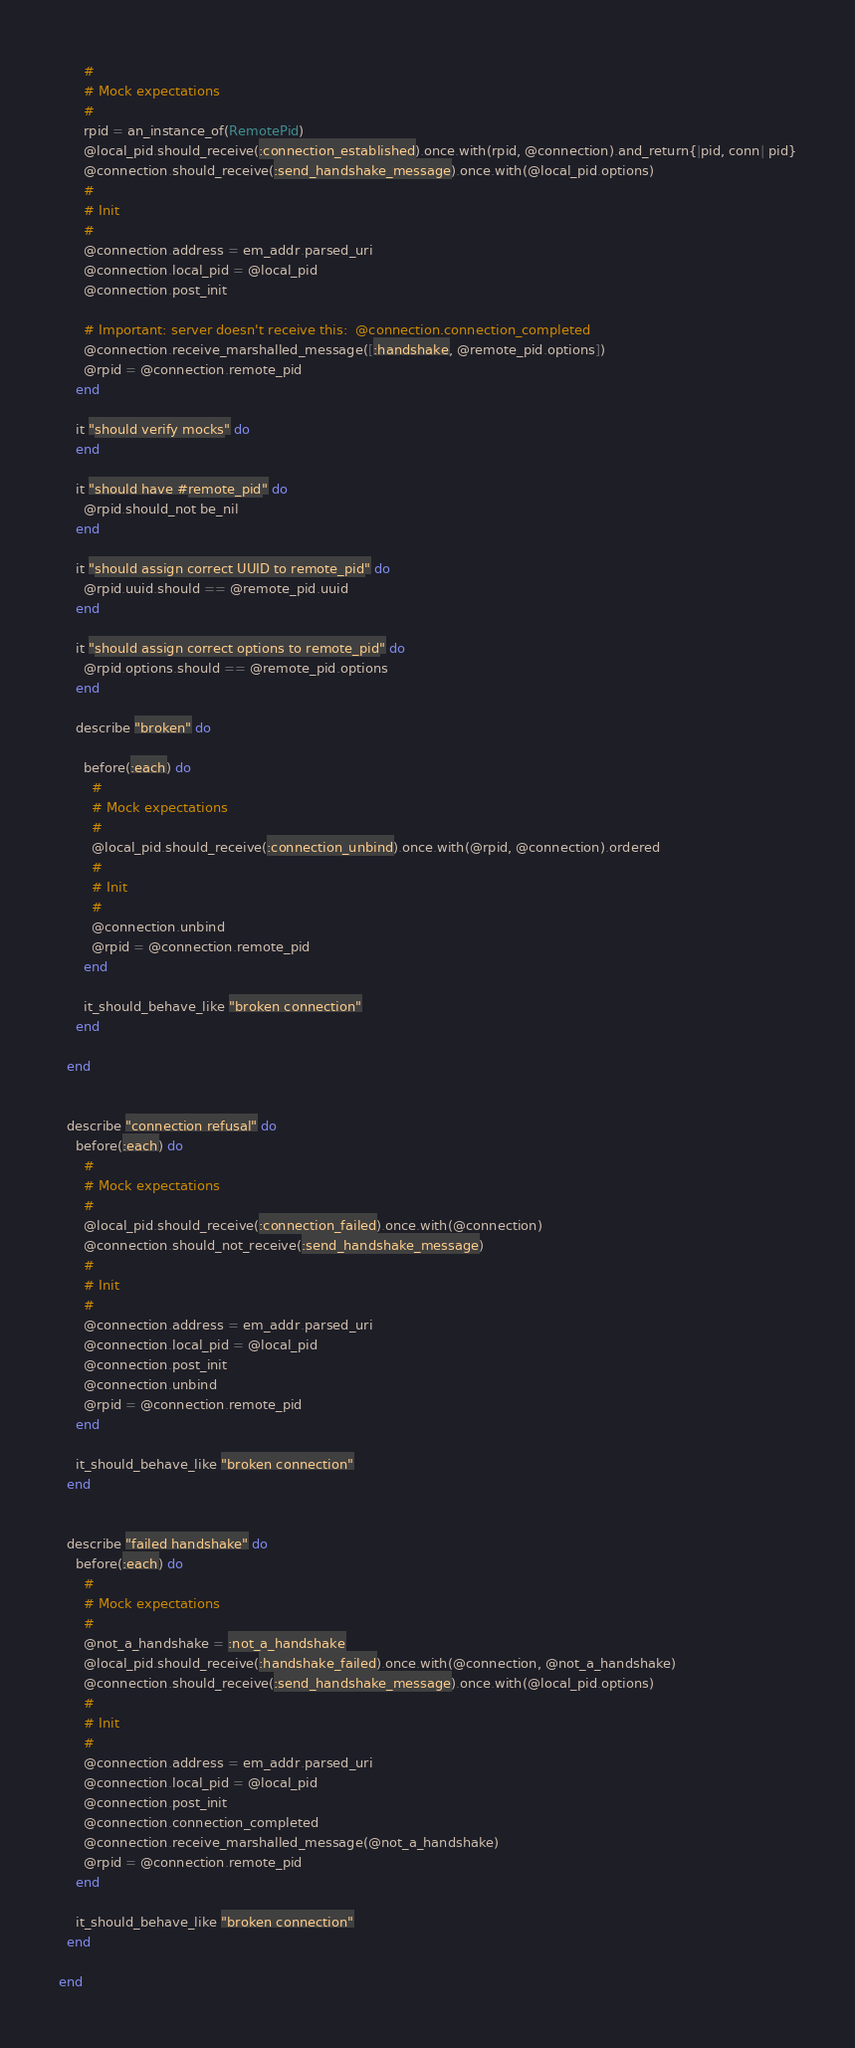<code> <loc_0><loc_0><loc_500><loc_500><_Ruby_>      #
      # Mock expectations
      #
      rpid = an_instance_of(RemotePid)
      @local_pid.should_receive(:connection_established).once.with(rpid, @connection).and_return{|pid, conn| pid}
      @connection.should_receive(:send_handshake_message).once.with(@local_pid.options)
      #
      # Init
      #
      @connection.address = em_addr.parsed_uri
      @connection.local_pid = @local_pid
      @connection.post_init
      
      # Important: server doesn't receive this:  @connection.connection_completed
      @connection.receive_marshalled_message([:handshake, @remote_pid.options])
      @rpid = @connection.remote_pid
    end
    
    it "should verify mocks" do
    end
    
    it "should have #remote_pid" do
      @rpid.should_not be_nil
    end
    
    it "should assign correct UUID to remote_pid" do
      @rpid.uuid.should == @remote_pid.uuid
    end
    
    it "should assign correct options to remote_pid" do
      @rpid.options.should == @remote_pid.options
    end
    
    describe "broken" do
      
      before(:each) do
        #
        # Mock expectations
        #
        @local_pid.should_receive(:connection_unbind).once.with(@rpid, @connection).ordered
        #
        # Init
        #
        @connection.unbind
        @rpid = @connection.remote_pid
      end
      
      it_should_behave_like "broken connection"
    end
    
  end
  
  
  describe "connection refusal" do
    before(:each) do
      #
      # Mock expectations
      #
      @local_pid.should_receive(:connection_failed).once.with(@connection)
      @connection.should_not_receive(:send_handshake_message)
      #
      # Init
      #
      @connection.address = em_addr.parsed_uri
      @connection.local_pid = @local_pid
      @connection.post_init
      @connection.unbind
      @rpid = @connection.remote_pid
    end
    
    it_should_behave_like "broken connection"
  end


  describe "failed handshake" do
    before(:each) do
      #
      # Mock expectations
      #
      @not_a_handshake = :not_a_handshake
      @local_pid.should_receive(:handshake_failed).once.with(@connection, @not_a_handshake)
      @connection.should_receive(:send_handshake_message).once.with(@local_pid.options)
      #
      # Init
      #
      @connection.address = em_addr.parsed_uri
      @connection.local_pid = @local_pid
      @connection.post_init
      @connection.connection_completed
      @connection.receive_marshalled_message(@not_a_handshake)
      @rpid = @connection.remote_pid
    end
    
    it_should_behave_like "broken connection"
  end
  
end
</code> 